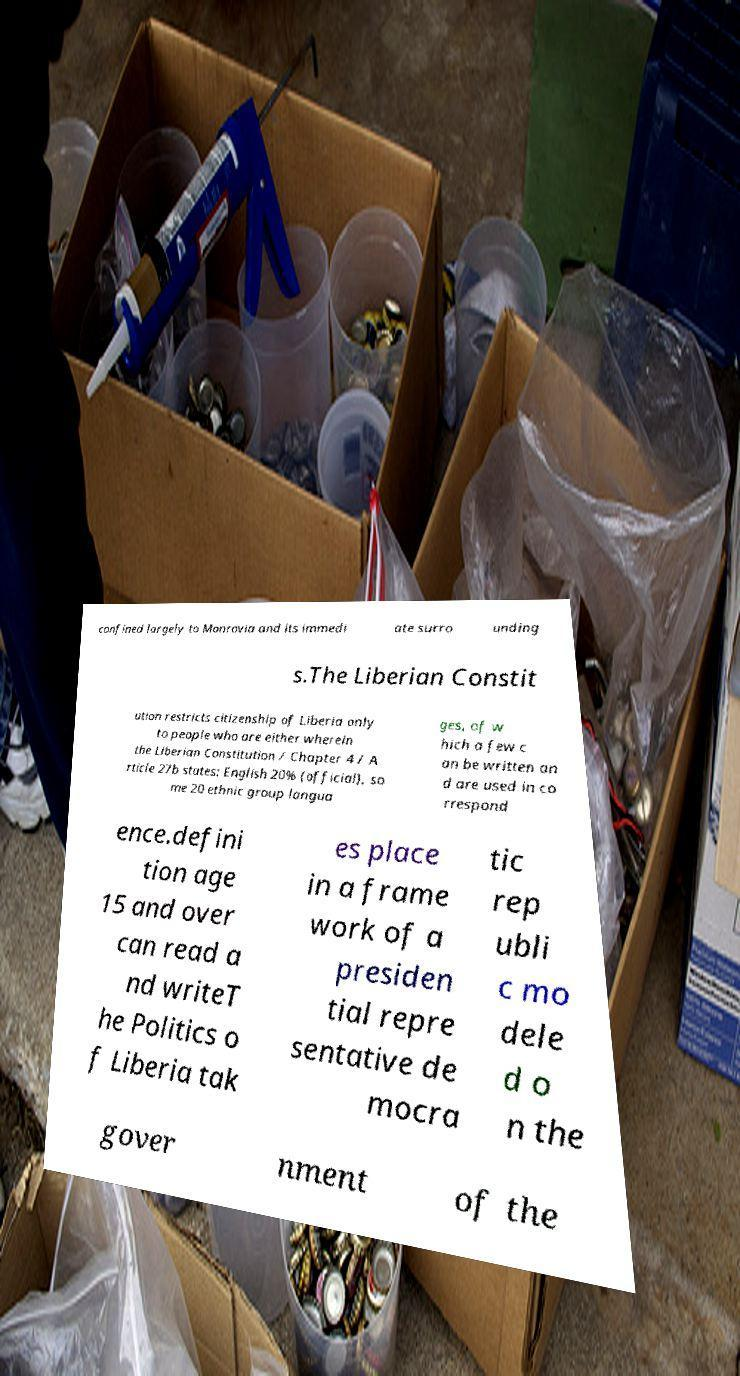Please read and relay the text visible in this image. What does it say? confined largely to Monrovia and its immedi ate surro unding s.The Liberian Constit ution restricts citizenship of Liberia only to people who are either wherein the Liberian Constitution / Chapter 4 / A rticle 27b states: English 20% (official), so me 20 ethnic group langua ges, of w hich a few c an be written an d are used in co rrespond ence.defini tion age 15 and over can read a nd writeT he Politics o f Liberia tak es place in a frame work of a presiden tial repre sentative de mocra tic rep ubli c mo dele d o n the gover nment of the 